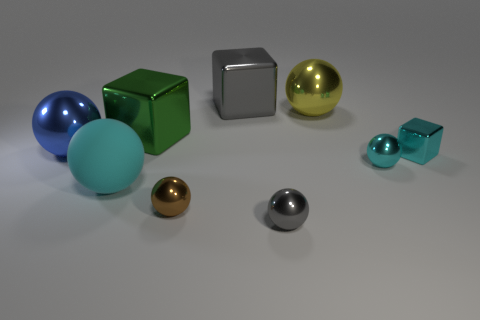Add 6 gray shiny objects. How many gray shiny objects exist? 8 Subtract all gray balls. How many balls are left? 5 Subtract all large blocks. How many blocks are left? 1 Subtract 1 cyan cubes. How many objects are left? 8 Subtract all spheres. How many objects are left? 3 Subtract 3 spheres. How many spheres are left? 3 Subtract all green balls. Subtract all yellow cubes. How many balls are left? 6 Subtract all blue balls. How many gray blocks are left? 1 Subtract all small metallic spheres. Subtract all big cyan balls. How many objects are left? 5 Add 8 big gray metal blocks. How many big gray metal blocks are left? 9 